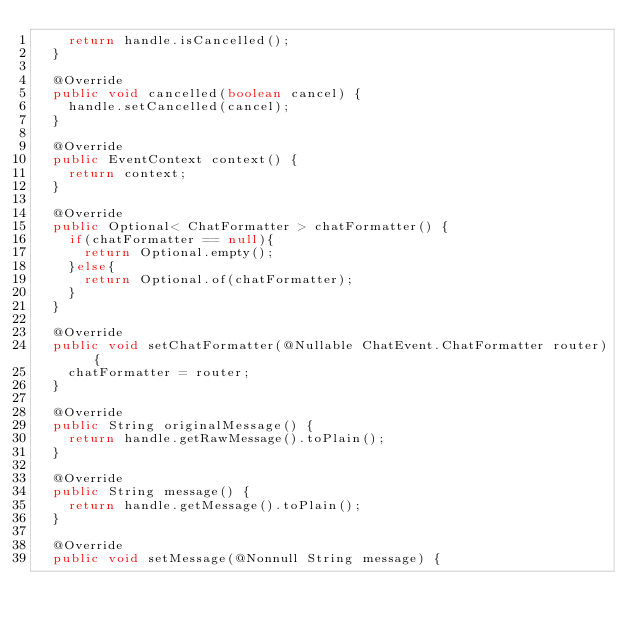Convert code to text. <code><loc_0><loc_0><loc_500><loc_500><_Java_>    return handle.isCancelled();
  }

  @Override
  public void cancelled(boolean cancel) {
    handle.setCancelled(cancel);
  }

  @Override
  public EventContext context() {
    return context;
  }

  @Override
  public Optional< ChatFormatter > chatFormatter() {
    if(chatFormatter == null){
      return Optional.empty();
    }else{
      return Optional.of(chatFormatter);
    }
  }

  @Override
  public void setChatFormatter(@Nullable ChatEvent.ChatFormatter router) {
    chatFormatter = router;
  }

  @Override
  public String originalMessage() {
    return handle.getRawMessage().toPlain();
  }

  @Override
  public String message() {
    return handle.getMessage().toPlain();
  }

  @Override
  public void setMessage(@Nonnull String message) {</code> 